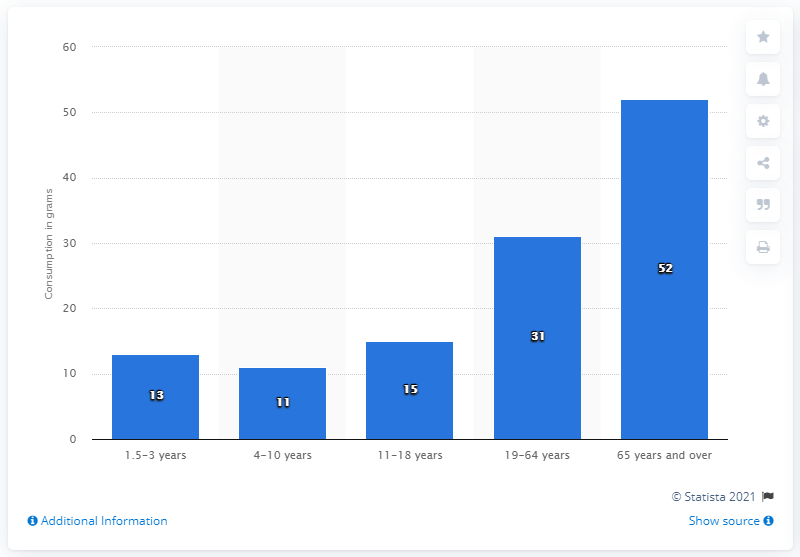Mention a couple of crucial points in this snapshot. Between 2008 and 2012, individuals aged 65 years and over consumed an average of 52 grams of soup per day. 